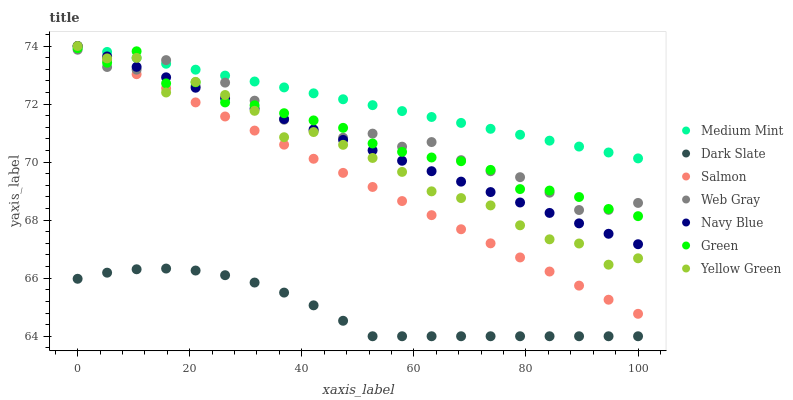Does Dark Slate have the minimum area under the curve?
Answer yes or no. Yes. Does Medium Mint have the maximum area under the curve?
Answer yes or no. Yes. Does Web Gray have the minimum area under the curve?
Answer yes or no. No. Does Web Gray have the maximum area under the curve?
Answer yes or no. No. Is Medium Mint the smoothest?
Answer yes or no. Yes. Is Yellow Green the roughest?
Answer yes or no. Yes. Is Web Gray the smoothest?
Answer yes or no. No. Is Web Gray the roughest?
Answer yes or no. No. Does Dark Slate have the lowest value?
Answer yes or no. Yes. Does Web Gray have the lowest value?
Answer yes or no. No. Does Salmon have the highest value?
Answer yes or no. Yes. Does Web Gray have the highest value?
Answer yes or no. No. Is Dark Slate less than Salmon?
Answer yes or no. Yes. Is Green greater than Dark Slate?
Answer yes or no. Yes. Does Salmon intersect Navy Blue?
Answer yes or no. Yes. Is Salmon less than Navy Blue?
Answer yes or no. No. Is Salmon greater than Navy Blue?
Answer yes or no. No. Does Dark Slate intersect Salmon?
Answer yes or no. No. 